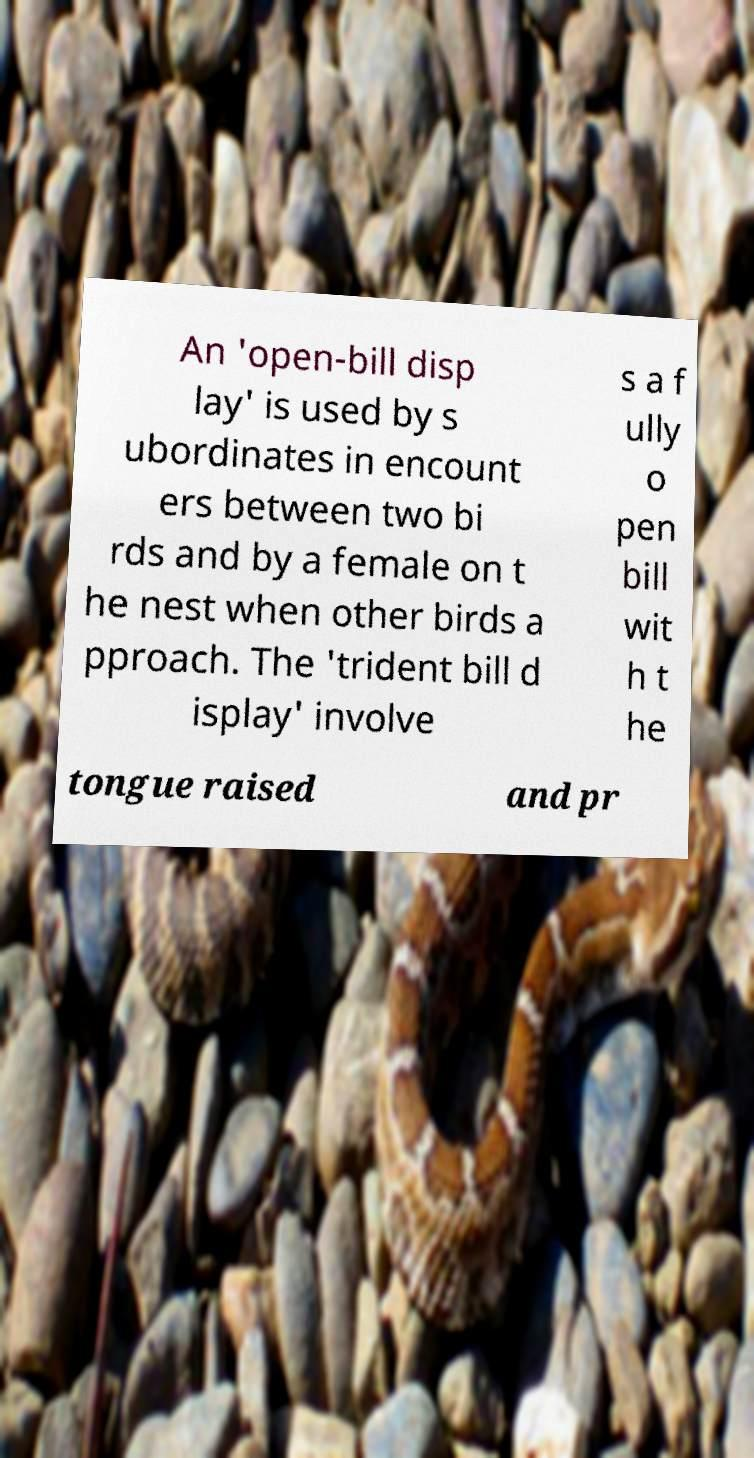Could you extract and type out the text from this image? An 'open-bill disp lay' is used by s ubordinates in encount ers between two bi rds and by a female on t he nest when other birds a pproach. The 'trident bill d isplay' involve s a f ully o pen bill wit h t he tongue raised and pr 